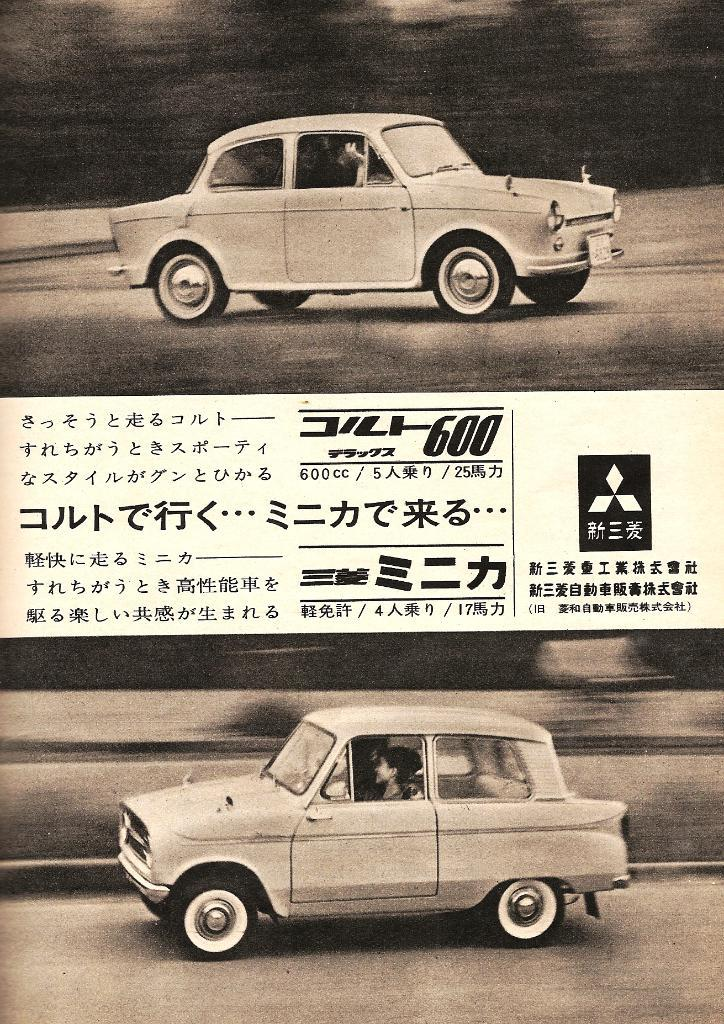What can be seen on the road in the image? There are two cars on the road in the image. What is located in the middle of the image? There is text or writing in the middle of the image. How is the image presented in terms of color? The image is in black and white. How many balls are visible in the image? There are no balls present in the image. What type of plant can be seen growing near the cars in the image? There is no plant visible in the image; it is a black and white image of two cars on the road and text in the middle. 